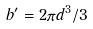Convert formula to latex. <formula><loc_0><loc_0><loc_500><loc_500>b ^ { \prime } = 2 \pi d ^ { 3 } / 3</formula> 